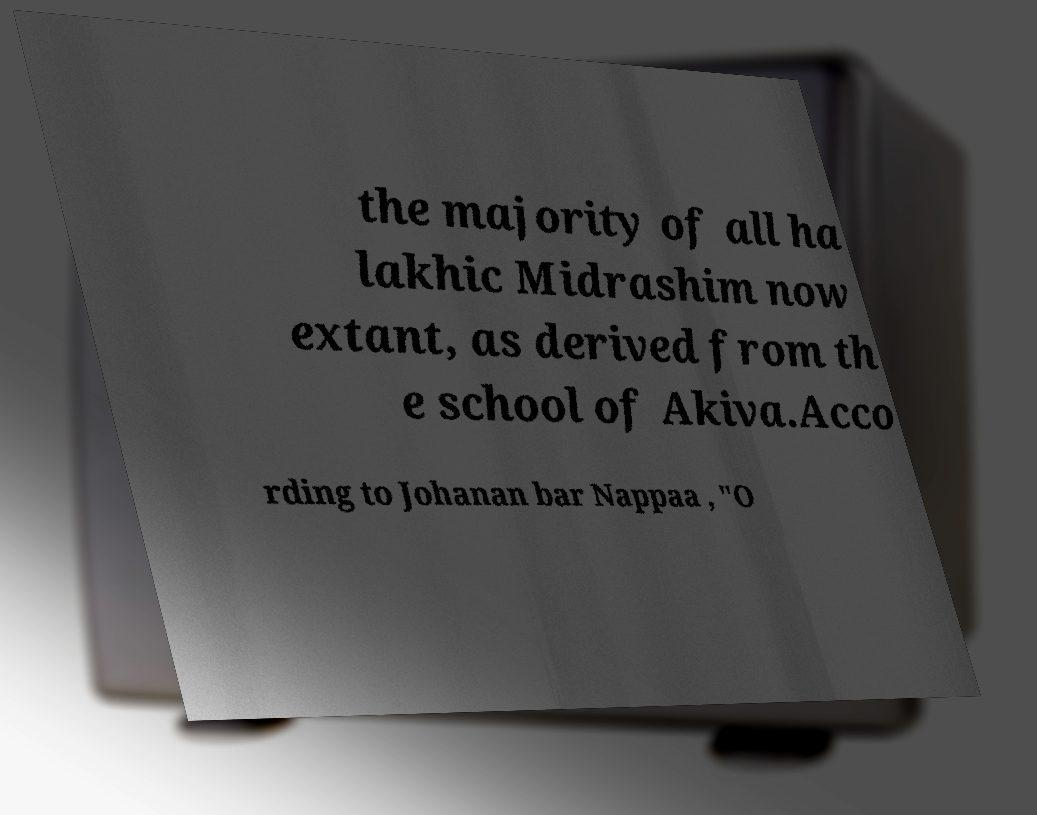Can you accurately transcribe the text from the provided image for me? the majority of all ha lakhic Midrashim now extant, as derived from th e school of Akiva.Acco rding to Johanan bar Nappaa , "O 